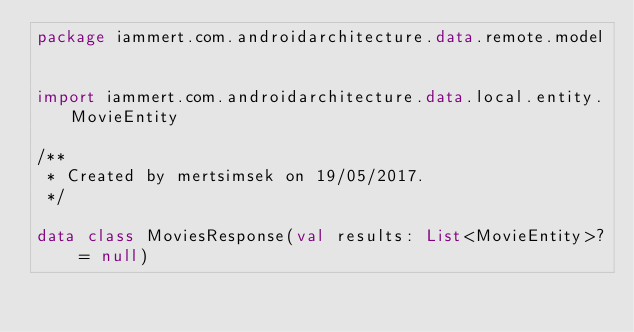Convert code to text. <code><loc_0><loc_0><loc_500><loc_500><_Kotlin_>package iammert.com.androidarchitecture.data.remote.model


import iammert.com.androidarchitecture.data.local.entity.MovieEntity

/**
 * Created by mertsimsek on 19/05/2017.
 */

data class MoviesResponse(val results: List<MovieEntity>? = null)
</code> 